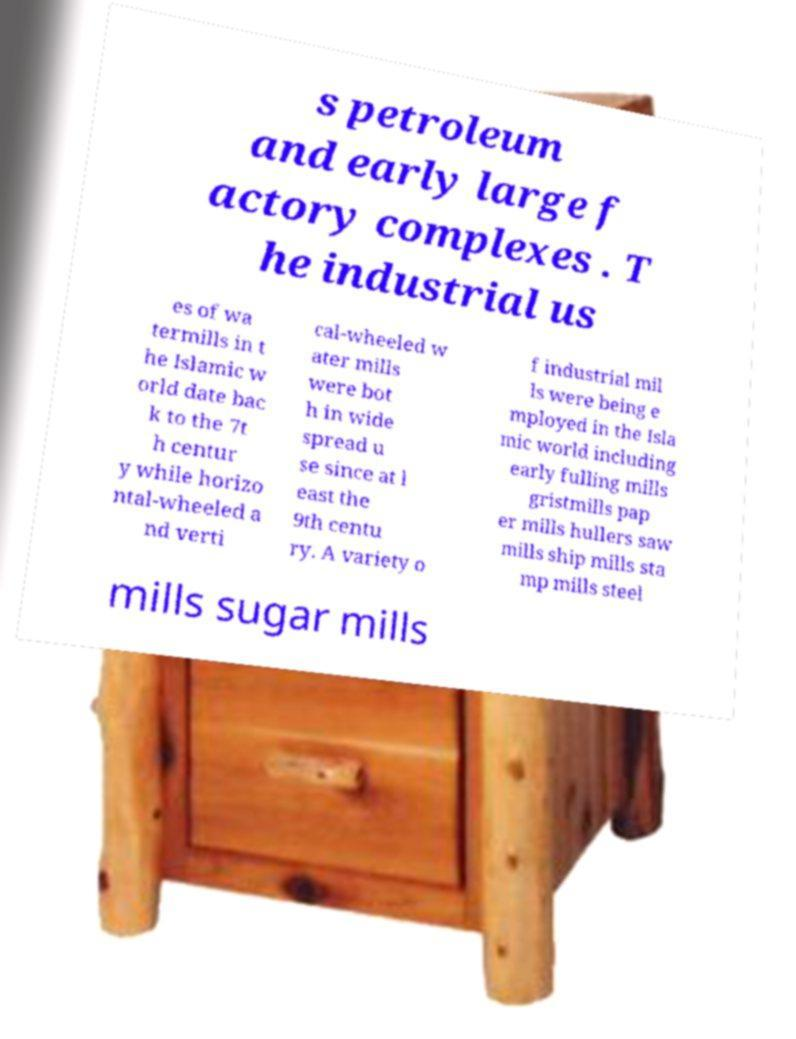Can you read and provide the text displayed in the image?This photo seems to have some interesting text. Can you extract and type it out for me? s petroleum and early large f actory complexes . T he industrial us es of wa termills in t he Islamic w orld date bac k to the 7t h centur y while horizo ntal-wheeled a nd verti cal-wheeled w ater mills were bot h in wide spread u se since at l east the 9th centu ry. A variety o f industrial mil ls were being e mployed in the Isla mic world including early fulling mills gristmills pap er mills hullers saw mills ship mills sta mp mills steel mills sugar mills 